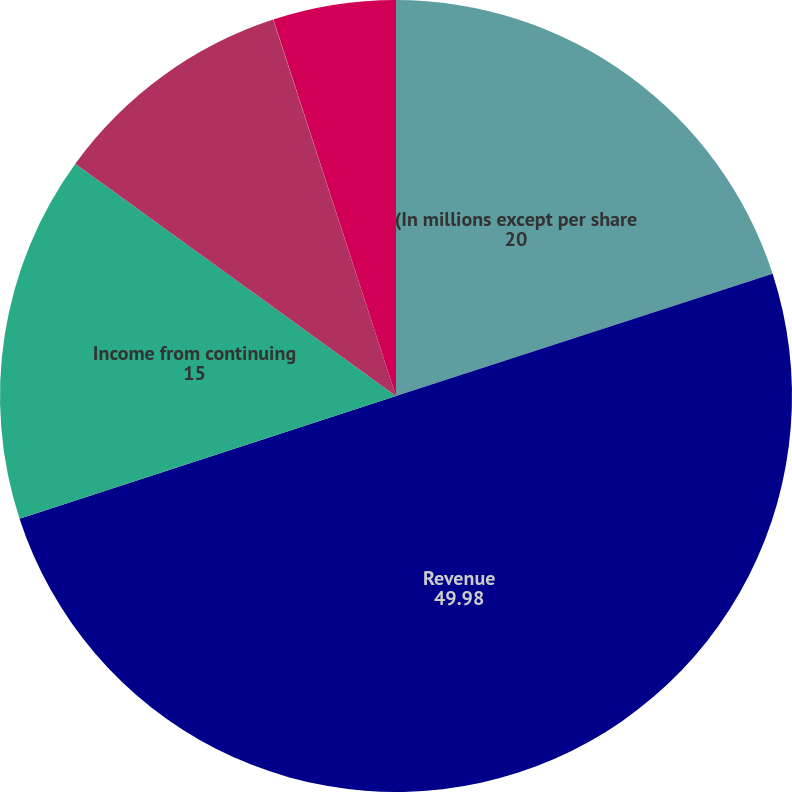Convert chart to OTSL. <chart><loc_0><loc_0><loc_500><loc_500><pie_chart><fcel>(In millions except per share<fcel>Revenue<fcel>Income from continuing<fcel>Net income attributable to the<fcel>- Continuing operations<fcel>- Net income attributable to<nl><fcel>20.0%<fcel>49.98%<fcel>15.0%<fcel>10.0%<fcel>0.01%<fcel>5.01%<nl></chart> 